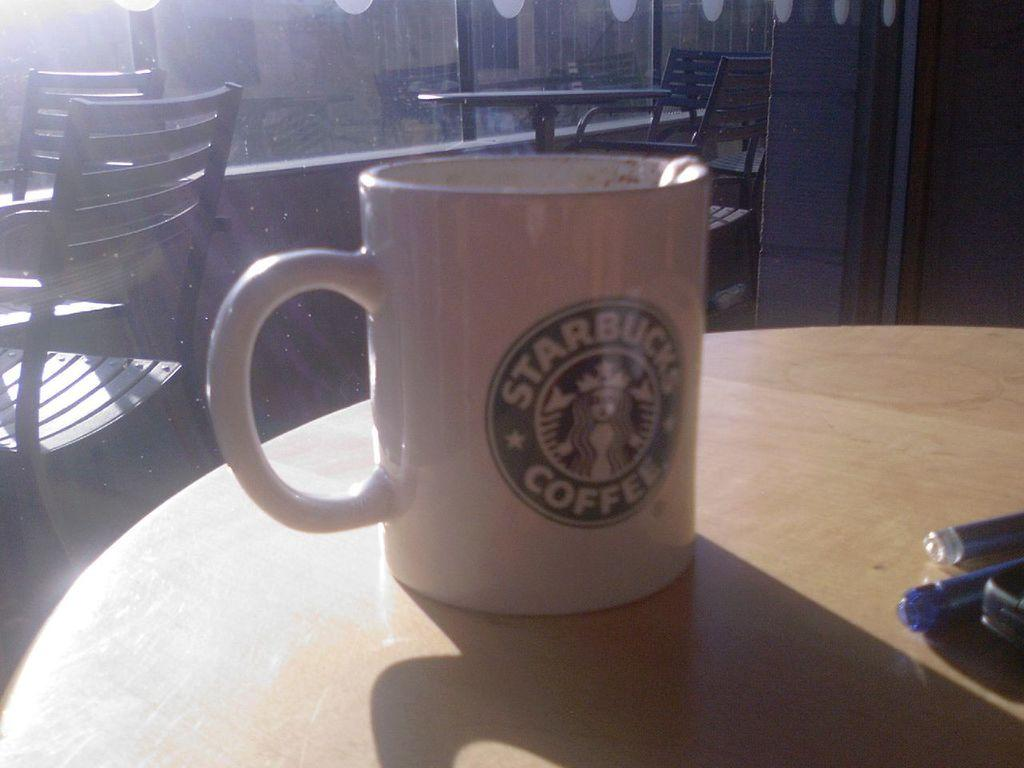<image>
Write a terse but informative summary of the picture. A coffee mug has the words Starbucks Coffee on it. 